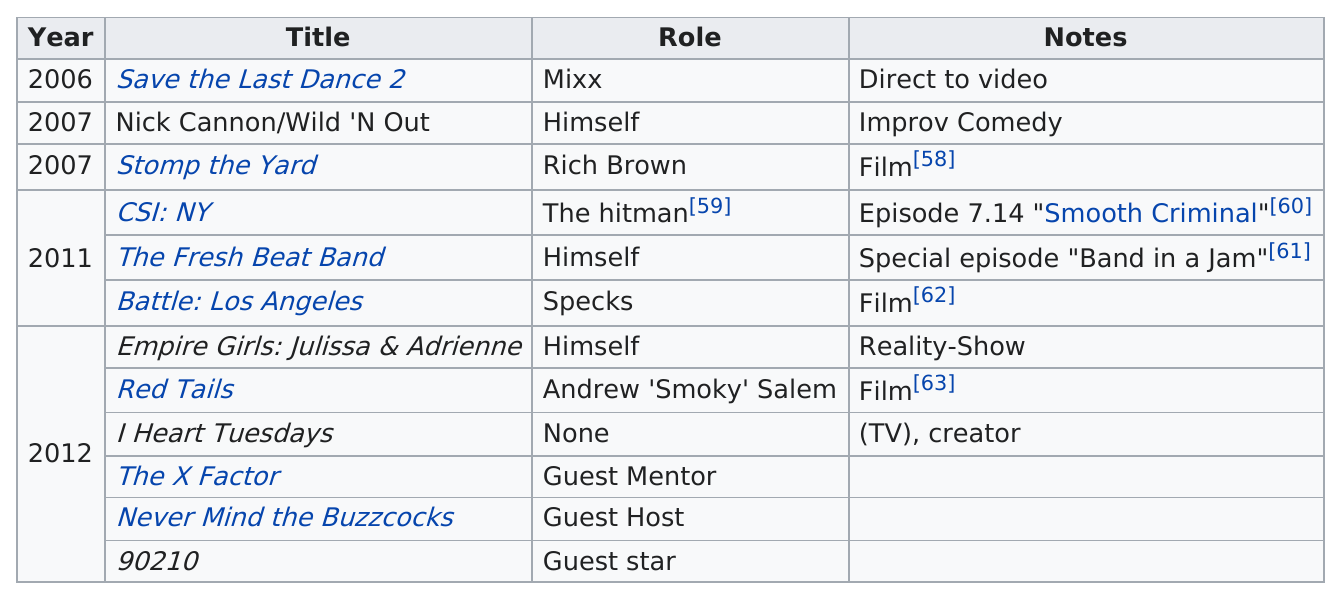Highlight a few significant elements in this photo. Ne-Yo played as Mixx 8 years ago. What was his role on The X Factor? He served as a guest mentor. 